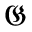Convert formula to latex. <formula><loc_0><loc_0><loc_500><loc_500>\mathfrak { G }</formula> 